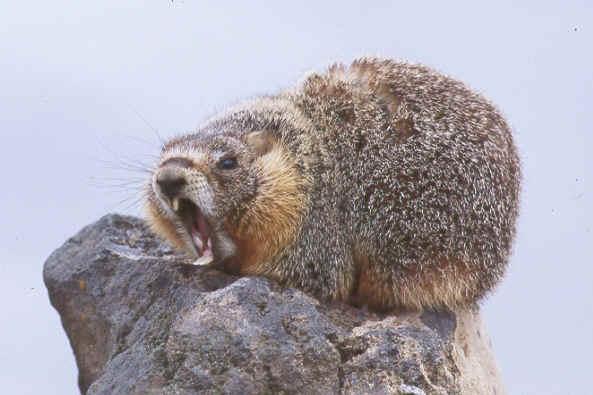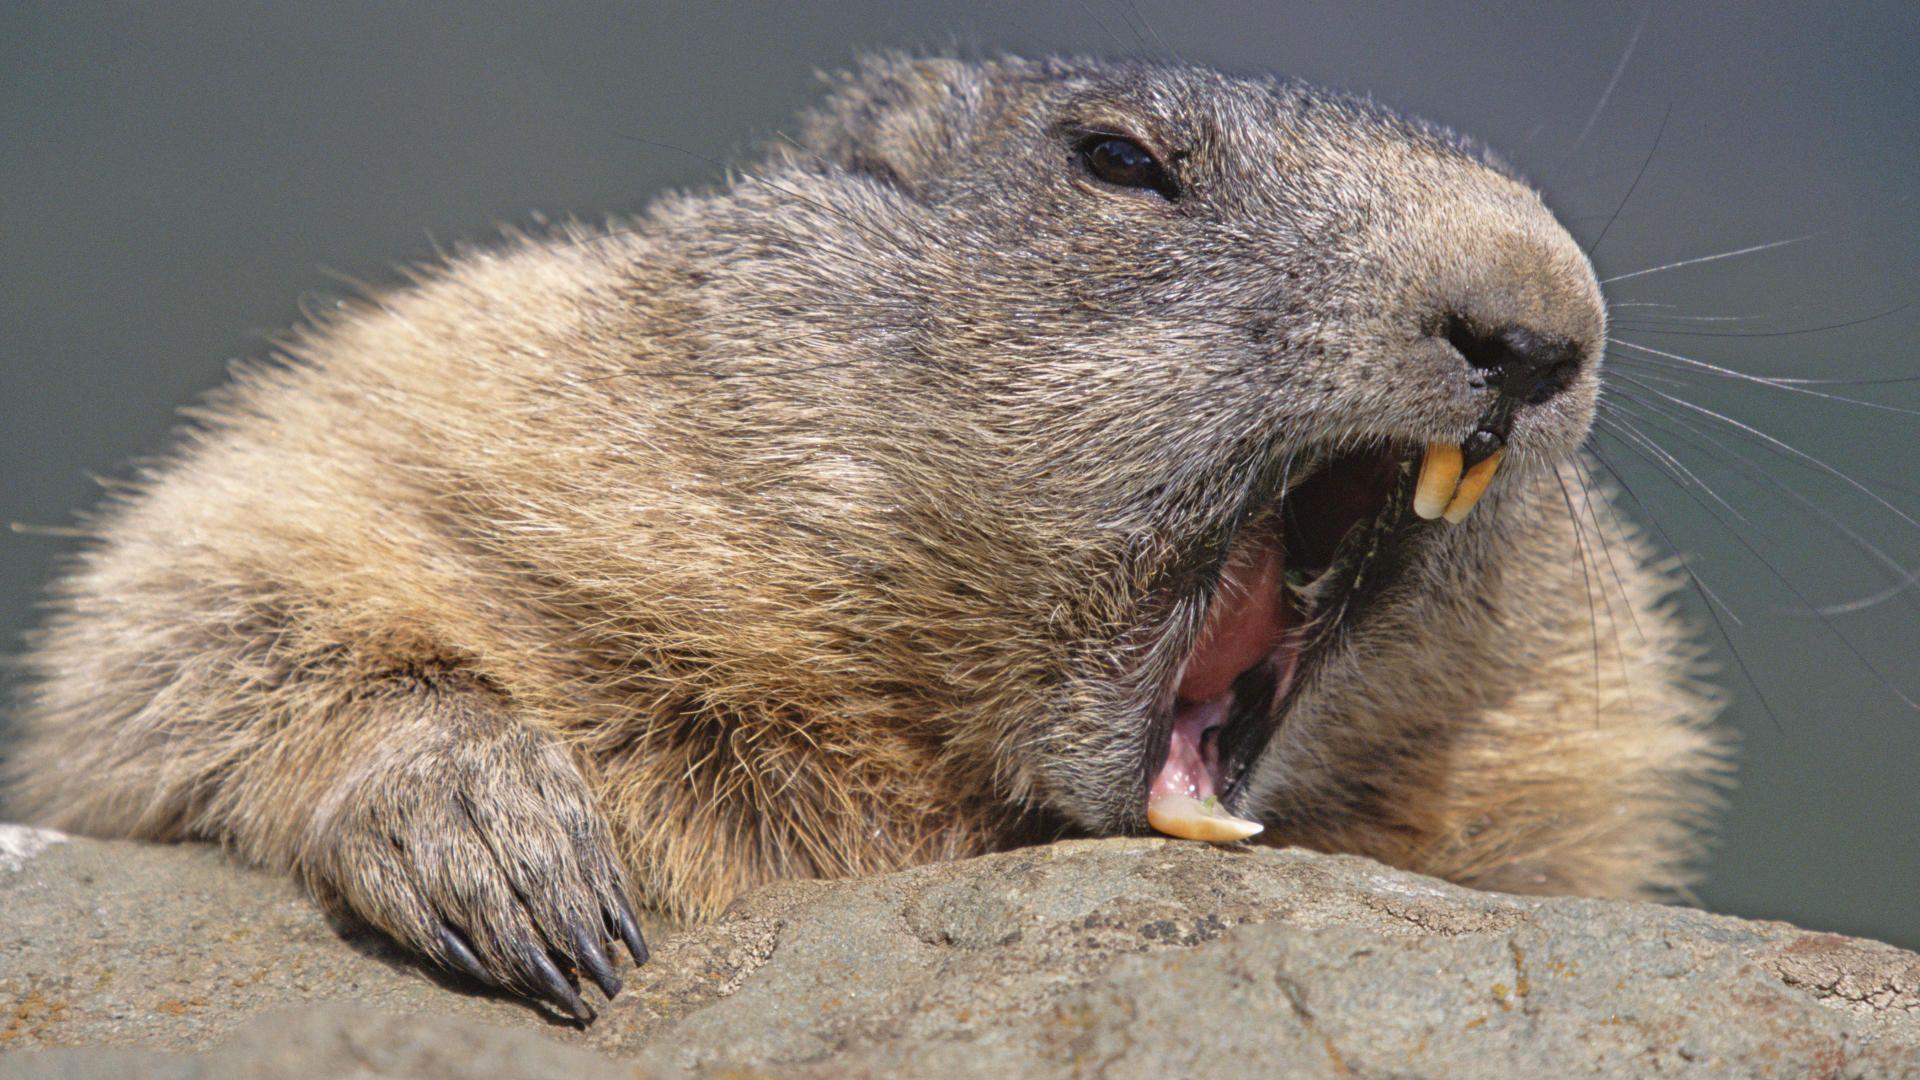The first image is the image on the left, the second image is the image on the right. Assess this claim about the two images: "The animal in the image on the right is looking toward the camera". Correct or not? Answer yes or no. No. 